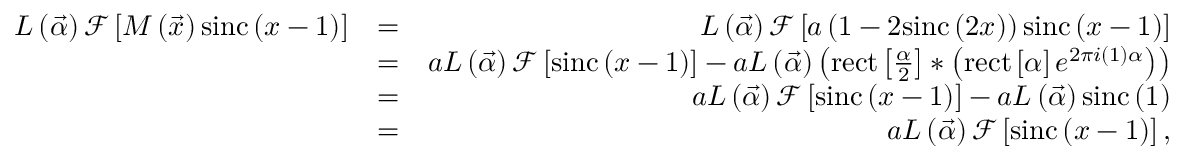Convert formula to latex. <formula><loc_0><loc_0><loc_500><loc_500>\begin{array} { r l r } { L \left ( \vec { \alpha } \right ) \mathcal { F } \left [ M \left ( \vec { x } \right ) \sin c \left ( x - 1 \right ) \right ] } & { = } & { L \left ( \vec { \alpha } \right ) \mathcal { F } \left [ a \left ( 1 - 2 \sin c \left ( 2 x \right ) \right ) \sin c \left ( x - 1 \right ) \right ] } \\ & { = } & { a L \left ( \vec { \alpha } \right ) \mathcal { F } \left [ \sin c \left ( x - 1 \right ) \right ] - a L \left ( \vec { \alpha } \right ) \left ( r e c t \left [ \frac { \alpha } { 2 } \right ] \ast \left ( r e c t \left [ \alpha \right ] e ^ { 2 \pi i \left ( 1 \right ) \alpha } \right ) \right ) } \\ & { = } & { a L \left ( \vec { \alpha } \right ) \mathcal { F } \left [ \sin c \left ( x - 1 \right ) \right ] - a L \left ( \vec { \alpha } \right ) \sin c \left ( 1 \right ) } \\ & { = } & { a L \left ( \vec { \alpha } \right ) \mathcal { F } \left [ \sin c \left ( x - 1 \right ) \right ] , } \end{array}</formula> 